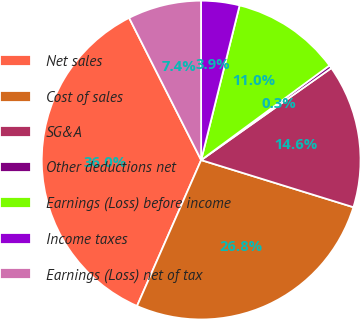<chart> <loc_0><loc_0><loc_500><loc_500><pie_chart><fcel>Net sales<fcel>Cost of sales<fcel>SG&A<fcel>Other deductions net<fcel>Earnings (Loss) before income<fcel>Income taxes<fcel>Earnings (Loss) net of tax<nl><fcel>35.95%<fcel>26.81%<fcel>14.57%<fcel>0.32%<fcel>11.01%<fcel>3.89%<fcel>7.45%<nl></chart> 